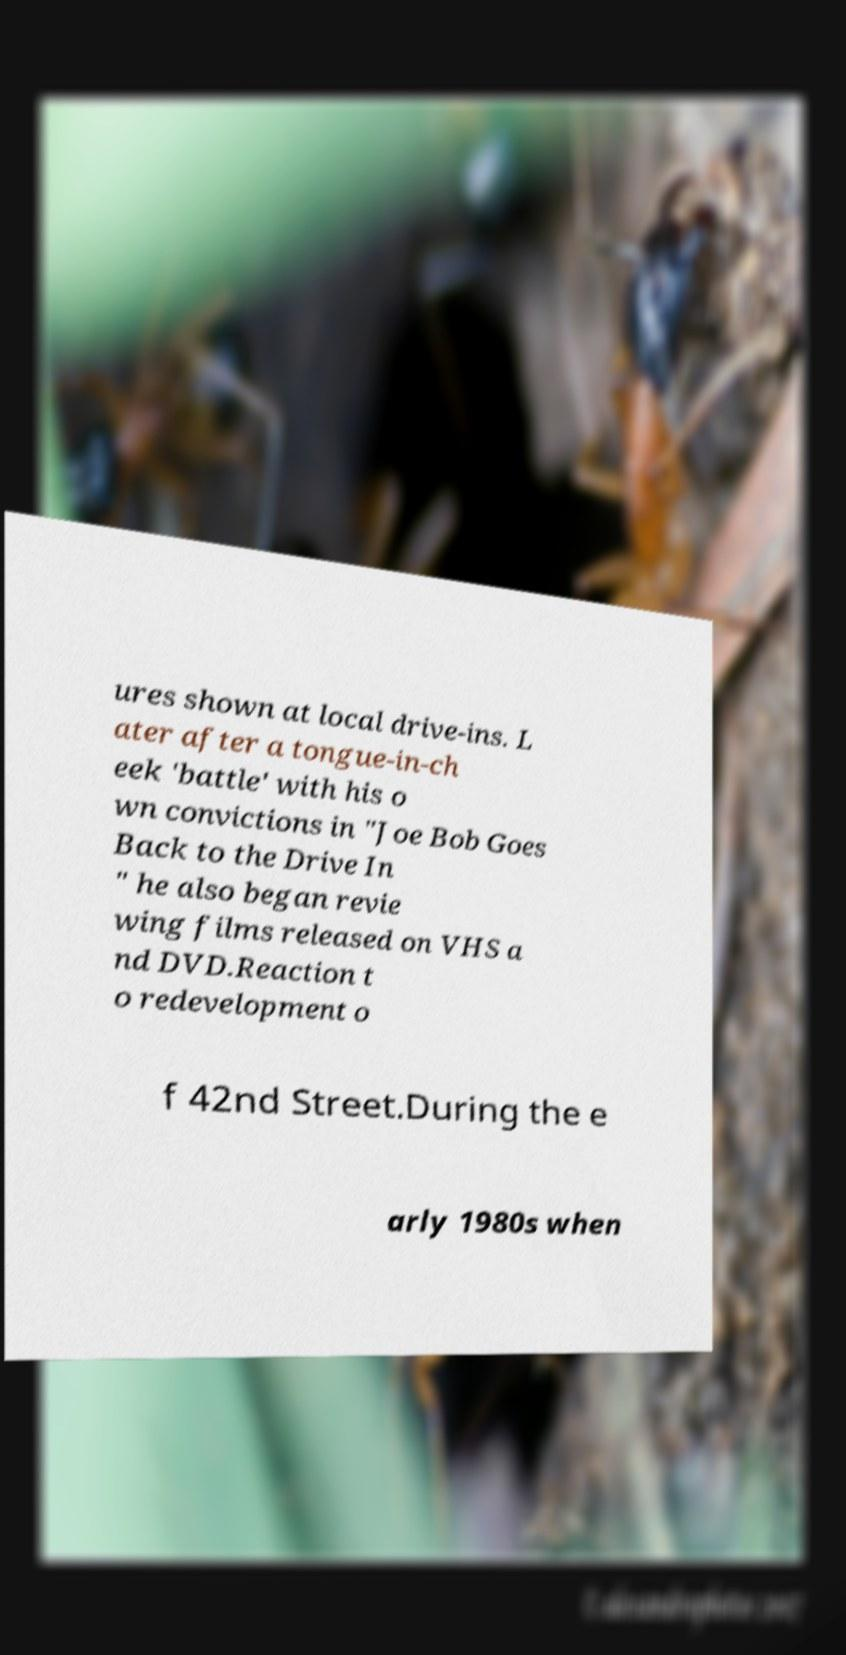Could you extract and type out the text from this image? ures shown at local drive-ins. L ater after a tongue-in-ch eek 'battle' with his o wn convictions in "Joe Bob Goes Back to the Drive In " he also began revie wing films released on VHS a nd DVD.Reaction t o redevelopment o f 42nd Street.During the e arly 1980s when 